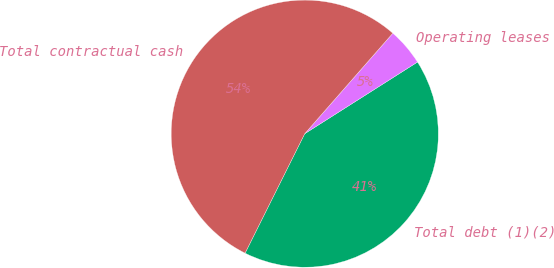Convert chart to OTSL. <chart><loc_0><loc_0><loc_500><loc_500><pie_chart><fcel>Total debt (1)(2)<fcel>Operating leases<fcel>Total contractual cash<nl><fcel>41.38%<fcel>4.54%<fcel>54.08%<nl></chart> 